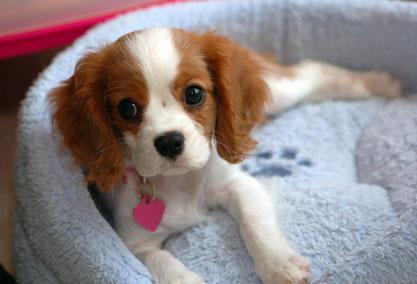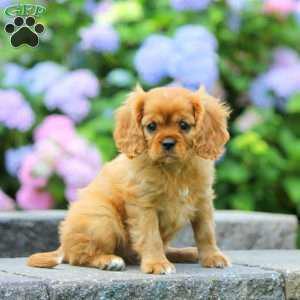The first image is the image on the left, the second image is the image on the right. Examine the images to the left and right. Is the description "There is at most 2 dogs." accurate? Answer yes or no. Yes. The first image is the image on the left, the second image is the image on the right. Analyze the images presented: Is the assertion "There is at least one image that shows exactly one dog in the grass." valid? Answer yes or no. No. 